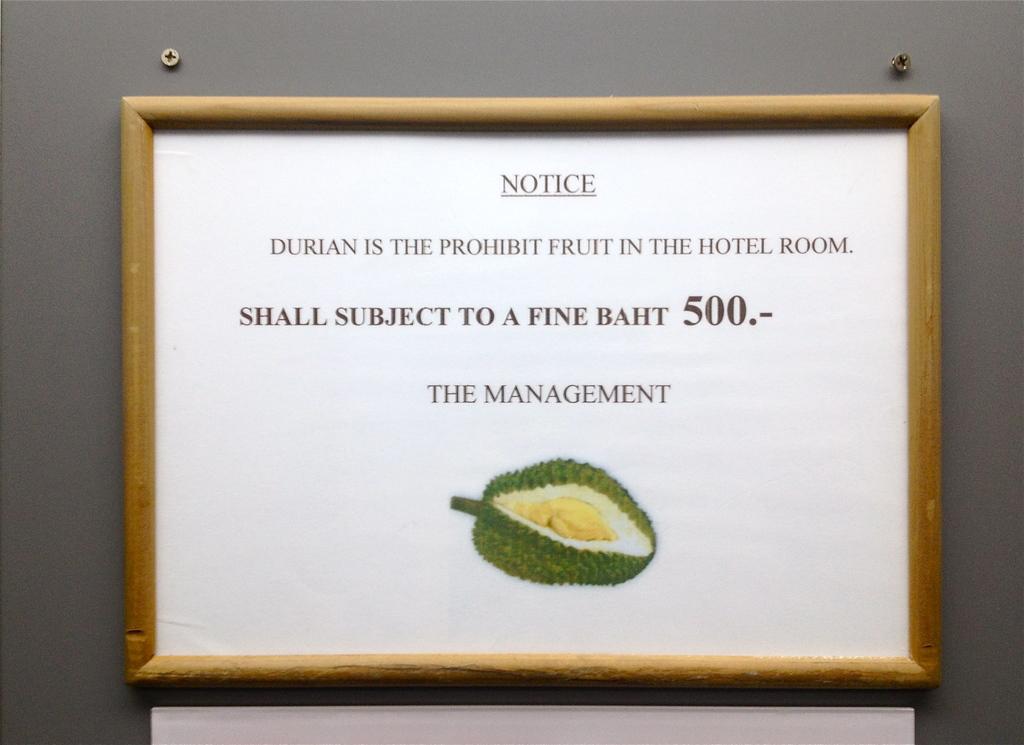Who wrote the message?
Ensure brevity in your answer.  The management. What is the fine?
Offer a very short reply. 500. 